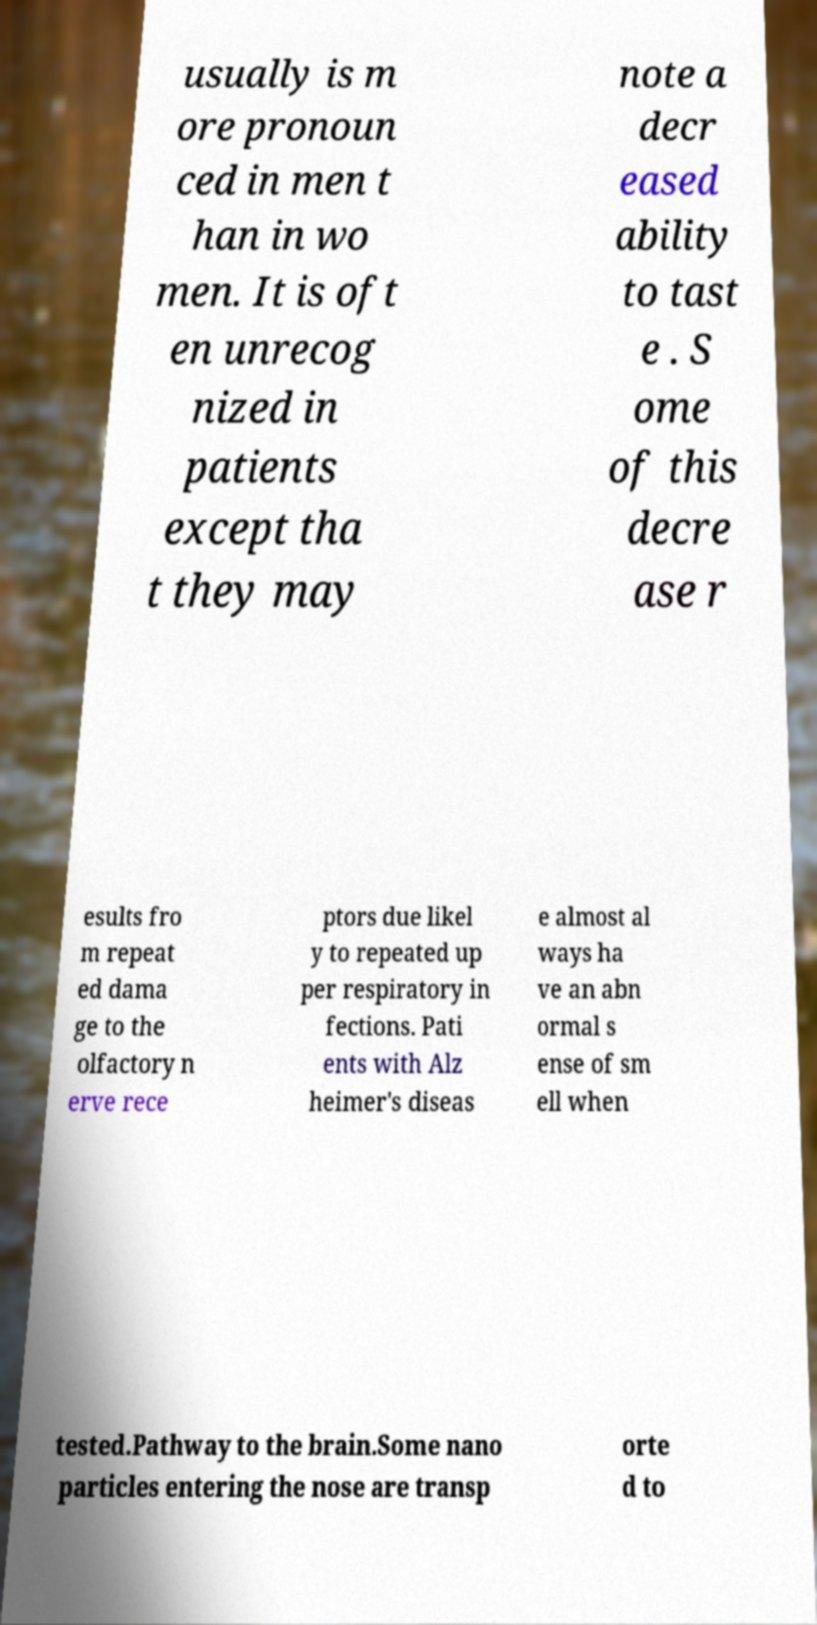I need the written content from this picture converted into text. Can you do that? usually is m ore pronoun ced in men t han in wo men. It is oft en unrecog nized in patients except tha t they may note a decr eased ability to tast e . S ome of this decre ase r esults fro m repeat ed dama ge to the olfactory n erve rece ptors due likel y to repeated up per respiratory in fections. Pati ents with Alz heimer's diseas e almost al ways ha ve an abn ormal s ense of sm ell when tested.Pathway to the brain.Some nano particles entering the nose are transp orte d to 